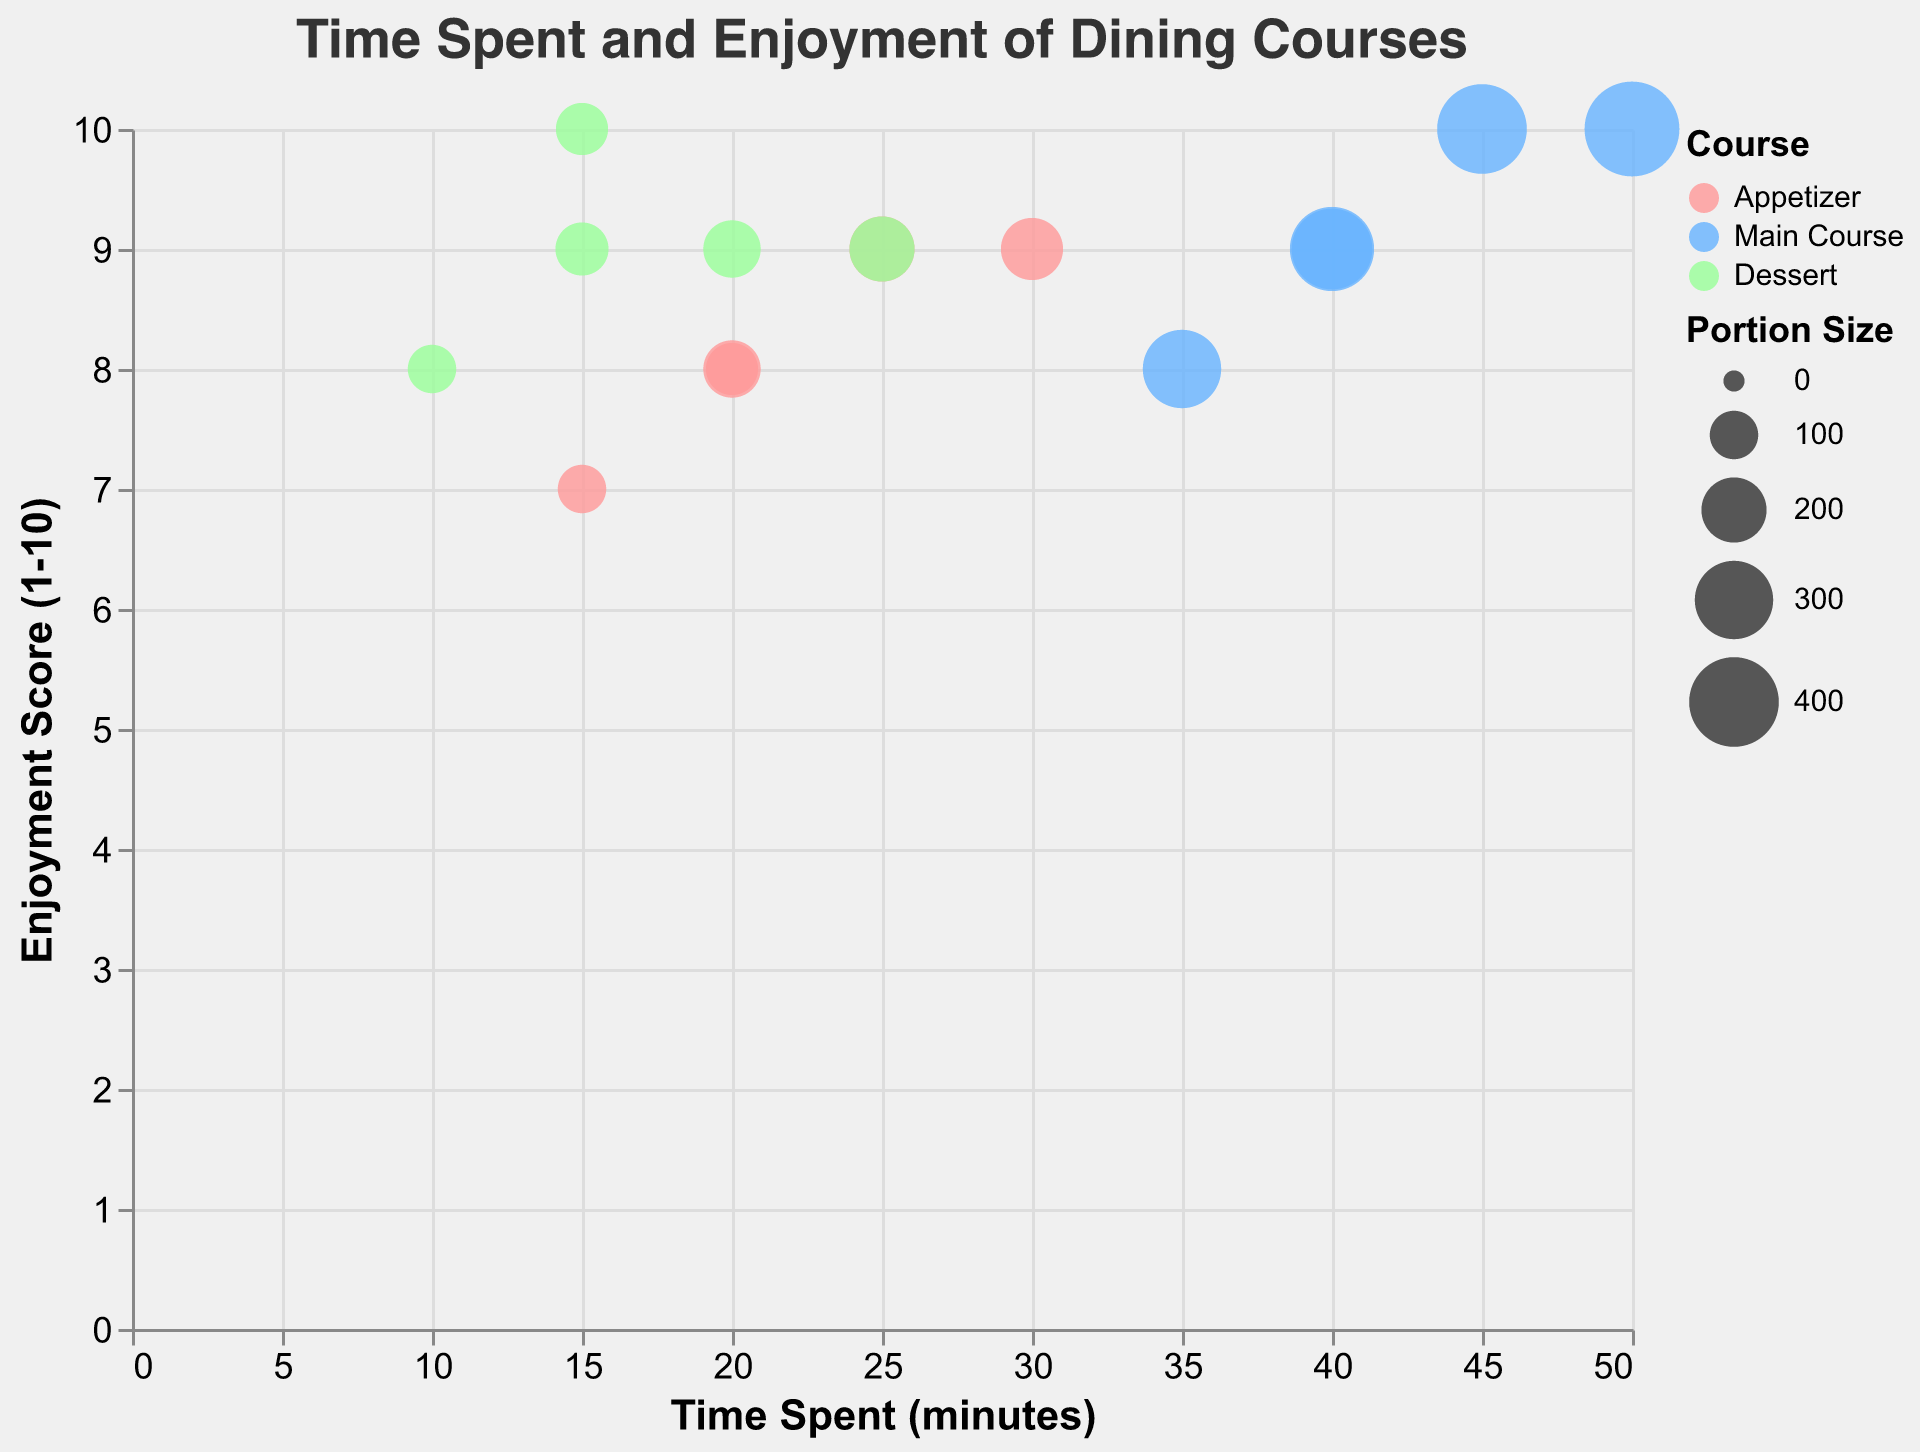What is the enjoyment score for dessert at The French Laundry? Look at the color representing "Dessert" on the chart at The French Laundry and find the corresponding enjoyment score on the y-axis.
Answer: 9 Which course and restaurant combination has the highest enjoyment score? Examine the y-axis for the course with the highest enjoyment score and find the corresponding restaurant and course from the tooltip or the color-coded course bubbles.
Answer: Eleven Madison Park, Main Course How much time is typically spent on dessert at Chez Panisse? Identify the bubble for dessert at Chez Panisse and check the x-axis to find the time spent.
Answer: 15 minutes Compare the enjoyment score of dessert at  Noma with the main course at Osteria Francescana. Which is higher? Assess the y-axis values for each course and restaurant mentioned and compare them to determine which is higher.
Answer: Noma, Dessert (9 is higher than 8) What is the average time spent on desserts across all restaurants? Sum the time spent on desserts for each restaurant: 15 (Chez Panisse) + 20 (Eleven Madison Park) + 10 (Osteria Francescana) + 25 (The French Laundry) + 15 (Noma) and divide by the number of restaurants (5).
Answer: 17 minutes Which restaurant spends the most time on their main course, and how long is it? Evaluate the time spent on the main course for each restaurant and identify the highest value on the x-axis.
Answer: The French Laundry, 50 minutes Are desserts proportionally larger or smaller than the main courses in terms of portion size? Compare the size of the bubbles representing desserts and main courses across different restaurants to see if dessert bubbles are generally smaller or larger.
Answer: Smaller What is the enjoyment score for appetizers at Eleven Madison Park and is it greater than or equal to the score for the main course? Check the y-axis values for appetizers and main courses at Eleven Madison Park to compare.
Answer: No (9 for appetizer, 10 for main course) What is the portion size for desserts at Noma? Find the bubble representing Noma's dessert and refer to its size cue to locate the portion size in the tooltip.
Answer: 125 Compare the average enjoyment score of desserts across all restaurants and main courses across all restaurants. Which has a higher average enjoyment score? Sum the enjoyment scores for desserts: 10 (Chez Panisse) + 9 (Eleven Madison Park) + 8 (Osteria Francescana) + 9 (The French Laundry) + 9 (Noma) and divide by 5 to get the average for desserts. Sum the enjoyment scores for main courses: 9 (Chez Panisse) + 10 (Eleven Madison Park) + 8 (Osteria Francescana) + 10 (The French Laundry) + 9 (Noma) and divide by 5 to get the average for main courses. Compare the two averages.
Answer: Desserts: 9, Main Courses: 9.2 (Main Courses have a slightly higher average score) 